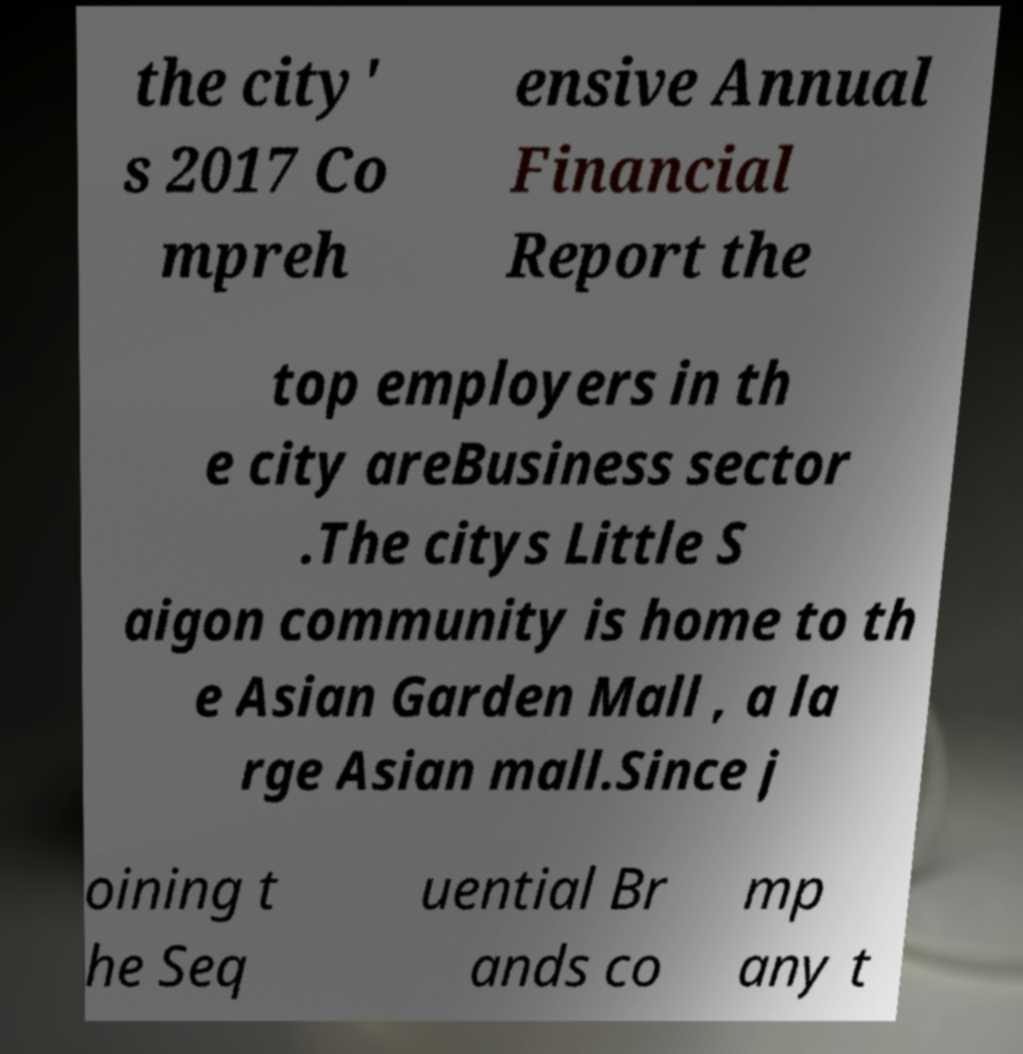Please read and relay the text visible in this image. What does it say? the city' s 2017 Co mpreh ensive Annual Financial Report the top employers in th e city areBusiness sector .The citys Little S aigon community is home to th e Asian Garden Mall , a la rge Asian mall.Since j oining t he Seq uential Br ands co mp any t 